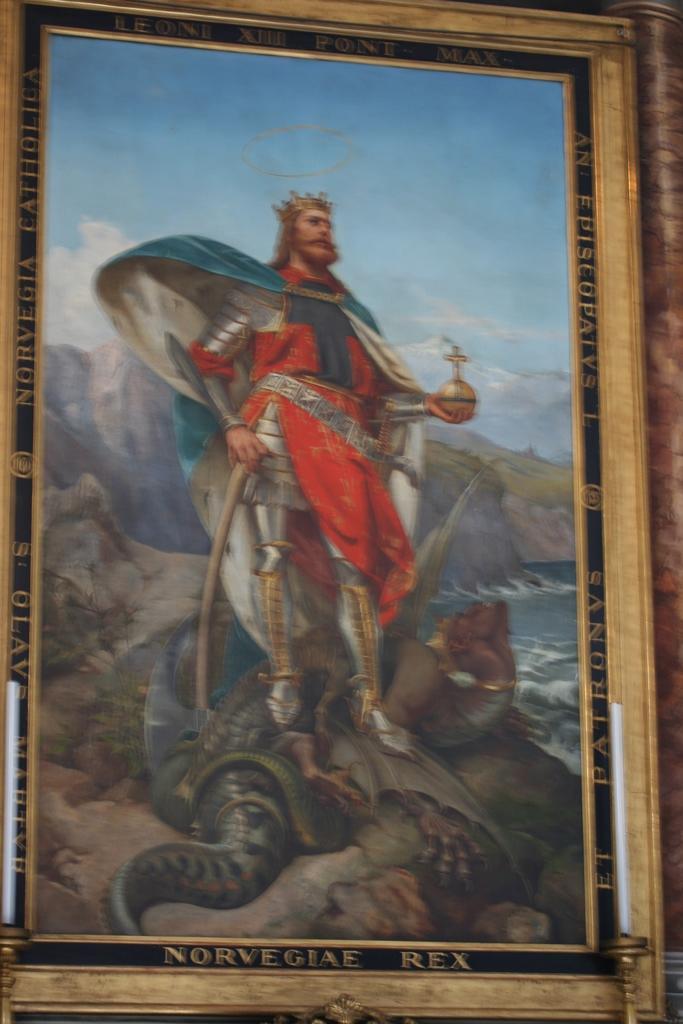How would you summarize this image in a sentence or two? In this image there is a picture frame having a picture of an animal. He is holding a stick with one hand and bottle with another hand. Behind him there is a hill. Top of image there is sky. 